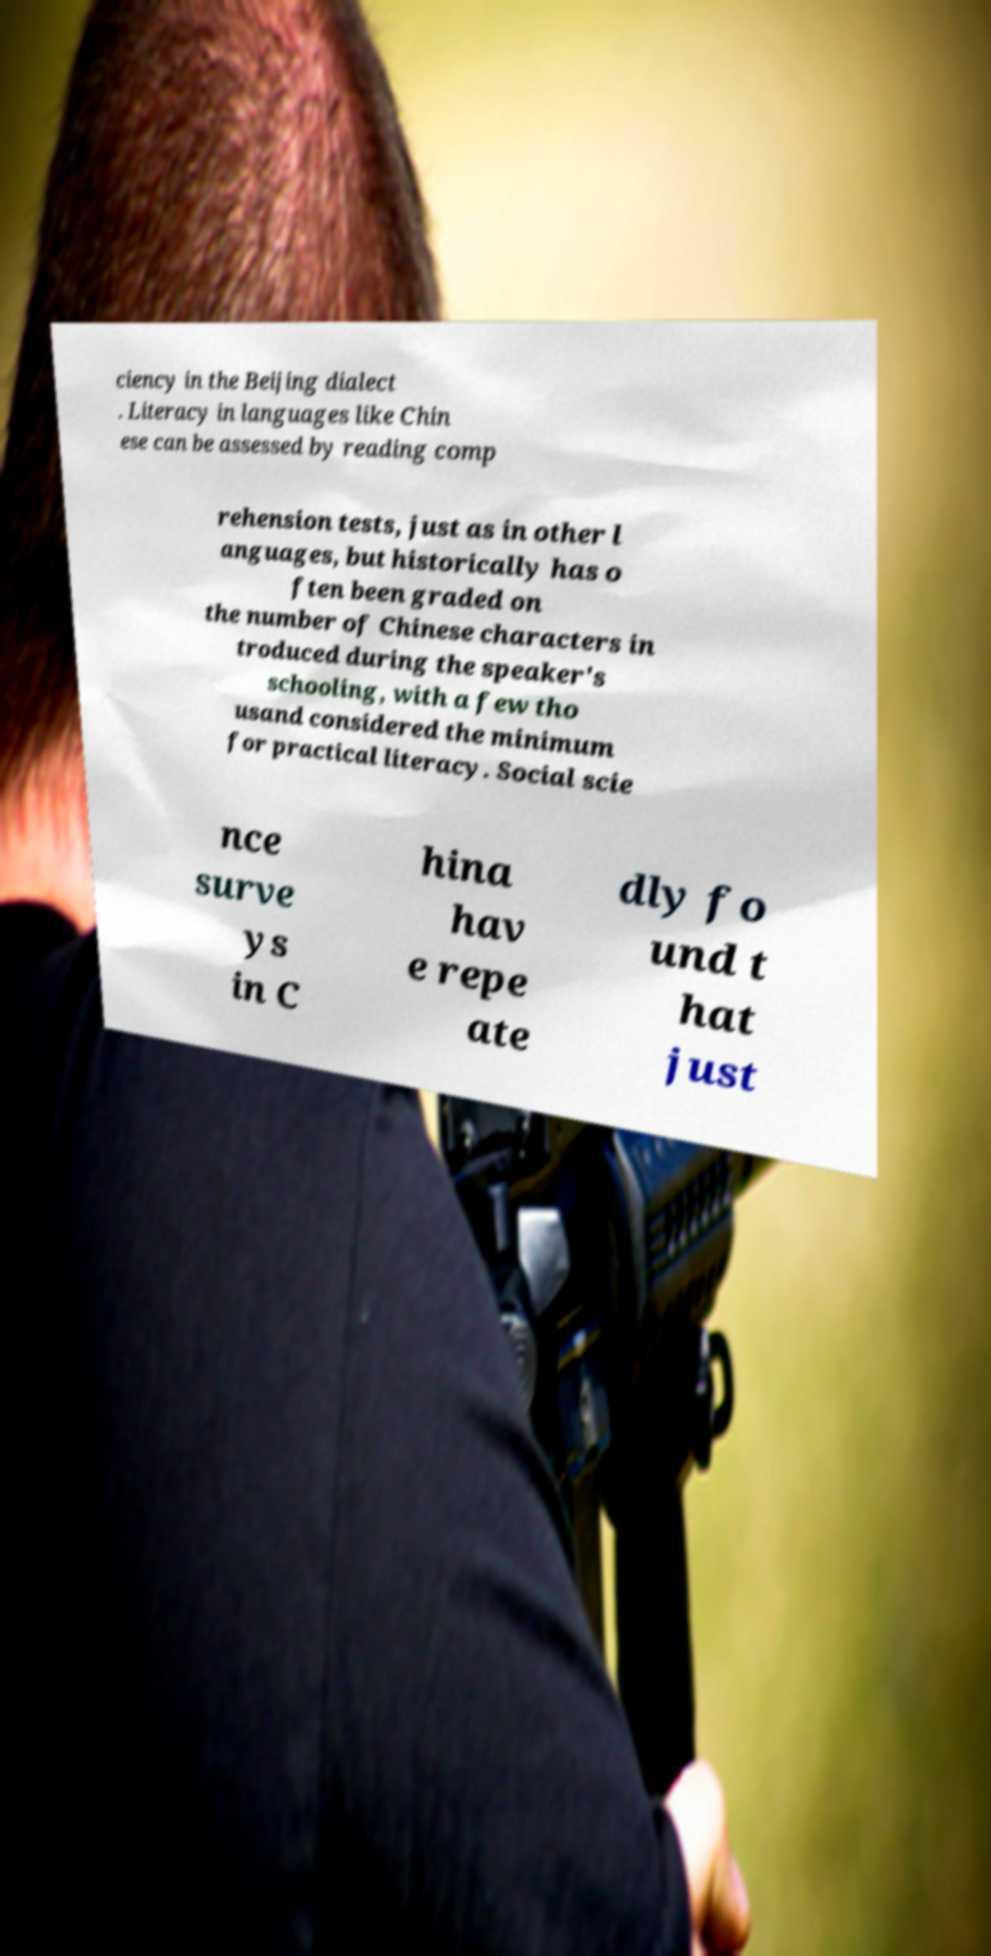For documentation purposes, I need the text within this image transcribed. Could you provide that? ciency in the Beijing dialect . Literacy in languages like Chin ese can be assessed by reading comp rehension tests, just as in other l anguages, but historically has o ften been graded on the number of Chinese characters in troduced during the speaker's schooling, with a few tho usand considered the minimum for practical literacy. Social scie nce surve ys in C hina hav e repe ate dly fo und t hat just 